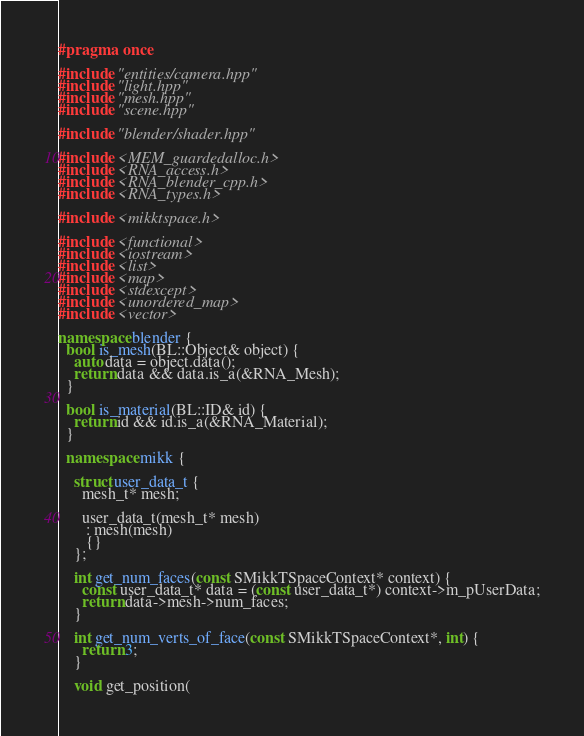Convert code to text. <code><loc_0><loc_0><loc_500><loc_500><_C++_>#pragma once

#include "entities/camera.hpp"
#include "light.hpp"
#include "mesh.hpp"
#include "scene.hpp"

#include "blender/shader.hpp"

#include <MEM_guardedalloc.h>
#include <RNA_access.h>
#include <RNA_blender_cpp.h>
#include <RNA_types.h>

#include <mikktspace.h>

#include <functional>
#include <iostream>
#include <list>
#include <map>
#include <stdexcept>
#include <unordered_map>
#include <vector>

namespace blender {
  bool is_mesh(BL::Object& object) {
    auto data = object.data();
    return data && data.is_a(&RNA_Mesh);
  }

  bool is_material(BL::ID& id) {
    return id && id.is_a(&RNA_Material);
  }

  namespace mikk {
  
    struct user_data_t {
      mesh_t* mesh;

      user_data_t(mesh_t* mesh) 
       : mesh(mesh)
       {}
    };

    int get_num_faces(const SMikkTSpaceContext* context) {
      const user_data_t* data = (const user_data_t*) context->m_pUserData;
      return data->mesh->num_faces;
    }

    int get_num_verts_of_face(const SMikkTSpaceContext*, int) {
      return 3;
    }

    void get_position(</code> 